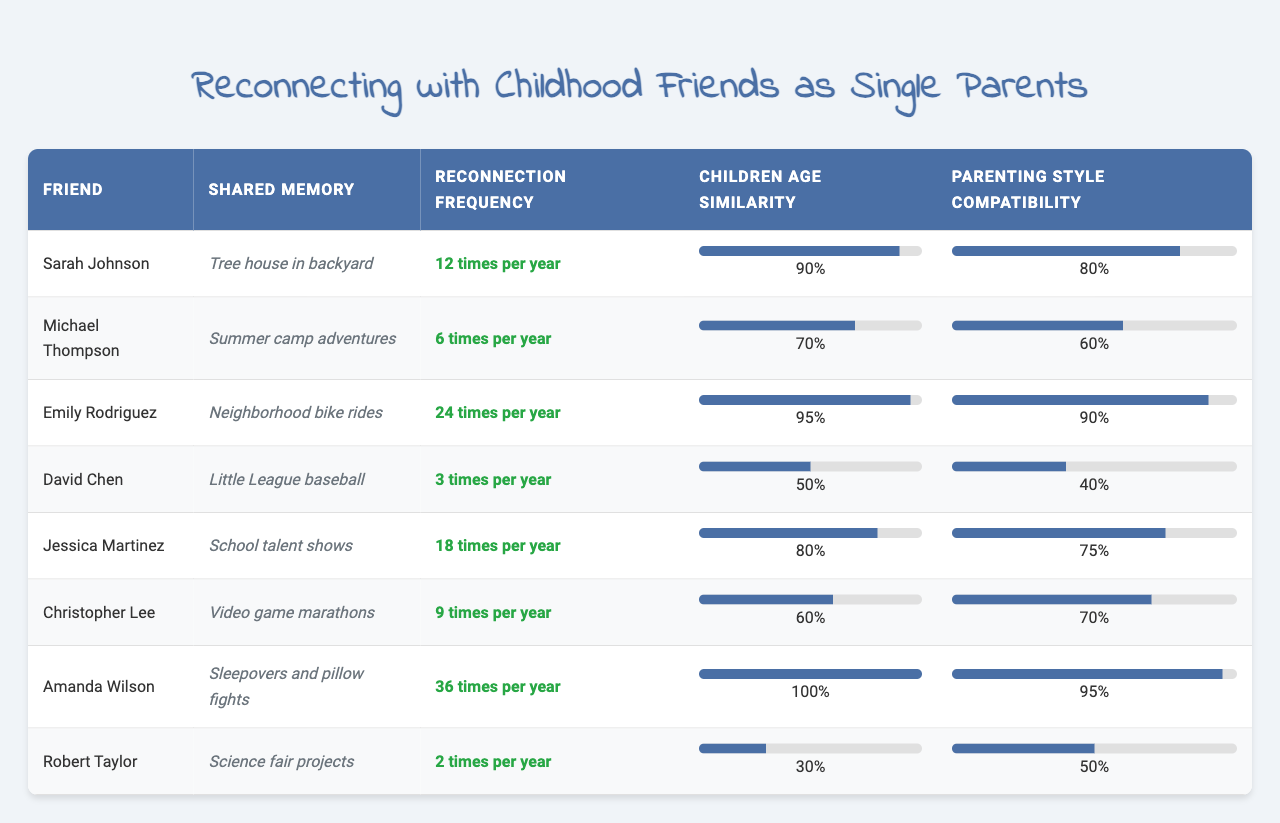What is the highest reconnection frequency among friends in the table? The table lists the reconnection frequencies for each friend. Amanda Wilson has the highest frequency at 36 times per year.
Answer: 36 Which friend has a shared childhood memory related to a tree house? According to the table, Sarah Johnson is associated with the shared childhood memory of a tree house in the backyard.
Answer: Sarah Johnson What is the average children’s age similarity among all the friends? To find the average, sum all the children age similarity values: (0.9 + 0.7 + 0.95 + 0.5 + 0.8 + 0.6 + 1.0 + 0.3) = 5.85. There are 8 friends, so the average is 5.85 / 8 = 0.73125, approximately 0.73 when rounded.
Answer: 0.73 Is there a friend with a parenting style compatibility of 1.0? The table shows no friend has a parenting style compatibility of 1.0; the closest is Amanda Wilson with 0.95.
Answer: No Which friend's shared memory involves 'Little League baseball' and what is their reconnection frequency? In the table, David Chen has the shared memory of 'Little League baseball', and his reconnection frequency is 3 times per year.
Answer: David Chen, 3 How many friends have a reconnection frequency of 10 or more times per year? By examining the table, the friends with a frequency of 10 or more are Sarah Johnson (12), Emily Rodriguez (24), Jessica Martinez (18), and Amanda Wilson (36), totaling 4 friends.
Answer: 4 What is the difference in parenting style compatibility between Amanda Wilson and David Chen? Amanda Wilson has a compatibility score of 0.95, while David Chen has 0.4. The difference is calculated as 0.95 - 0.4 = 0.55.
Answer: 0.55 Which friend's children's age similarity is the lowest, and what is that value? The friend with the lowest children age similarity in the table is Robert Taylor, with a value of 0.3.
Answer: Robert Taylor, 0.3 If you combine the reconnection frequencies of Emily Rodriguez and Jessica Martinez, what total do you get? Emily Rodriguez's frequency is 24, while Jessica Martinez's is 18. Adding them together gives 24 + 18 = 42.
Answer: 42 Which friend has the most compatible parenting style and what is that percentage? Amanda Wilson has the most compatible parenting style in the table with a score of 0.95.
Answer: 0.95 